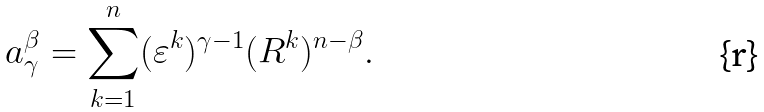Convert formula to latex. <formula><loc_0><loc_0><loc_500><loc_500>a _ { \gamma } ^ { \beta } = \underset { k = 1 } { \overset { n } { \sum } } ( \varepsilon ^ { k } ) ^ { \gamma - 1 } ( R ^ { k } ) ^ { n - \beta } .</formula> 